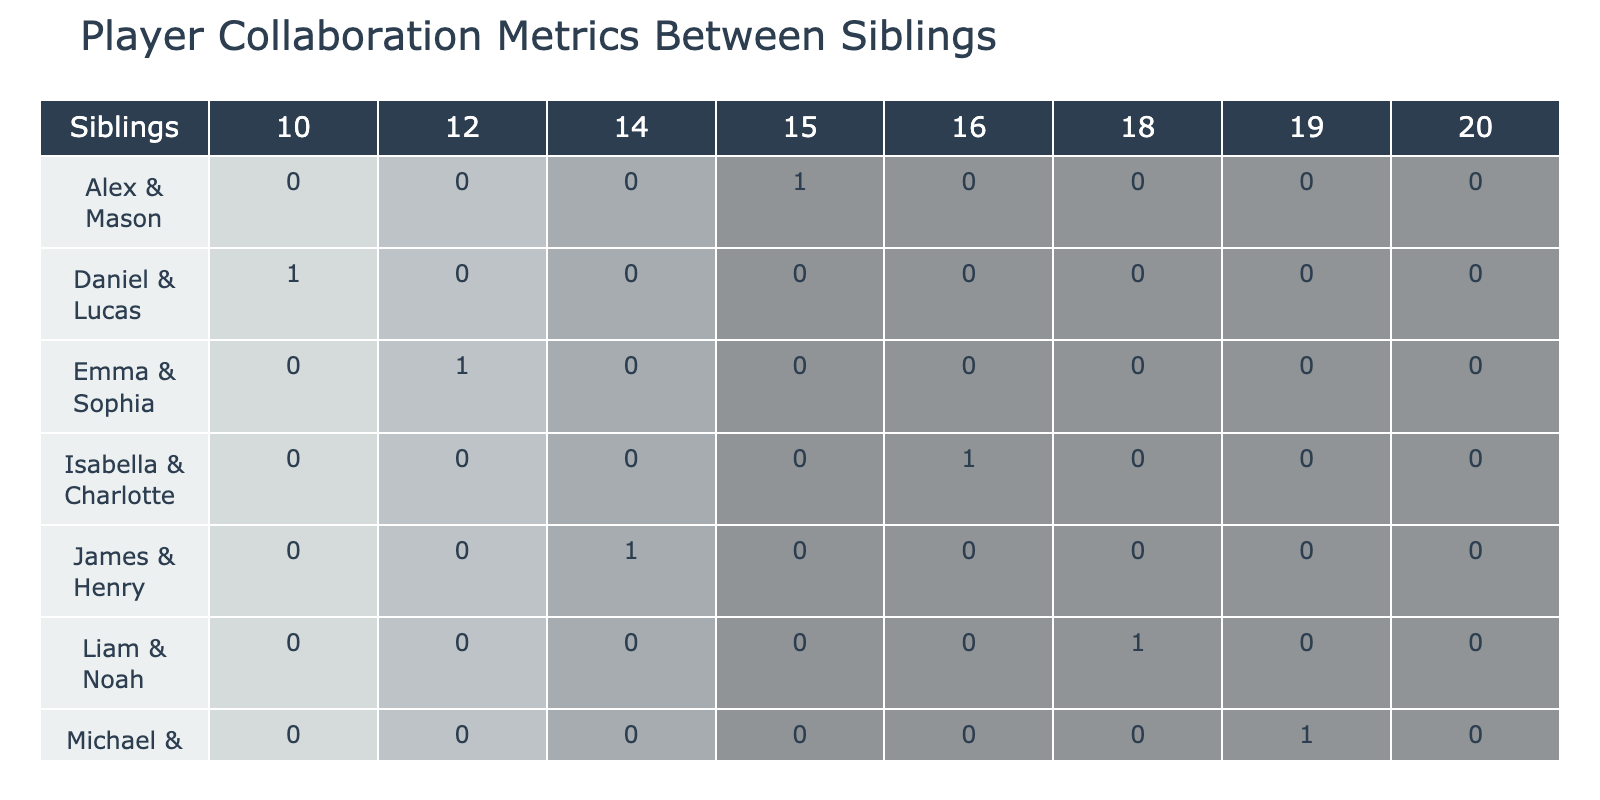What is the highest number of passes completed by a pair of siblings? The table shows the "Passes Completed" for each sibling pair. Looking through the values, Olivia and Ava have the highest with 20 passes completed.
Answer: 20 Which sibling duo recorded the least defensive interceptions? By checking the "Defensive Interceptions" column, Daniel and Lucas recorded the least with 8 interceptions.
Answer: 8 Did any sibling pair achieve an assist without scoring a goal? Reviewing the table, Daniel and Lucas made 0 assists and scored 1 goal, which means they scored without an assist. Thus, the answer is no, they did not record an assist.
Answer: No What total number of goals were scored by Alex and Mason combined? Alex and Mason scored 1 goal together. Since there is only one entry for these siblings, their total is simply 1.
Answer: 1 Which sibling pair had the highest combined number of assists? Looking at the "Assist" column, Isabella and Charlotte combined for 4 assists, which is the highest when summed across pairs (4). Other pairs had fewer combined assists.
Answer: 4 What is the average number of passes completed by the sibling pairs? To find the average, sum all passes completed (15 + 18 + 12 + 20 + 14 + 16 + 19 + 10) = 114. There are 8 pairs, so average = 114/8 = 14.25.
Answer: 14.25 Is it true that Liam and Noah had more goals than Emma and Sophia? Emma and Sophia scored a total of 2 goals while Liam and Noah scored 0 goals, so it is false that Liam and Noah had more goals.
Answer: No What is the combined number of defensive interceptions for Michael and Ethan and Olivia and Ava? Michael and Ethan had 5 interceptions and Olivia and Ava had 2 interceptions, combining for a total of (5 + 2) = 7 interceptions.
Answer: 7 Which sibling pair scored exactly 2 goals? Checking the "Goals" column, Emma and Sophia scored 2 goals, which is the only pair with this exact amount.
Answer: Emma and Sophia 